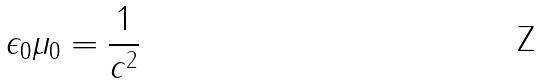Convert formula to latex. <formula><loc_0><loc_0><loc_500><loc_500>\epsilon _ { 0 } \mu _ { 0 } = \frac { 1 } { c ^ { 2 } }</formula> 